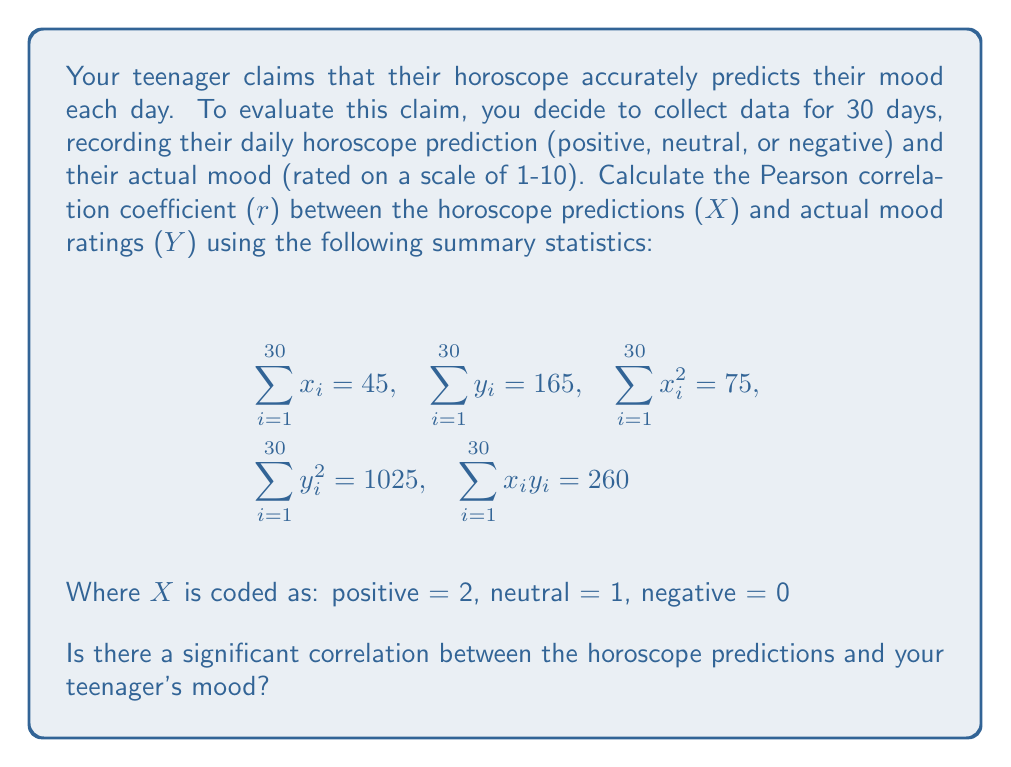Help me with this question. To calculate the Pearson correlation coefficient (r), we'll use the formula:

$$r = \frac{n\sum x_iy_i - (\sum x_i)(\sum y_i)}{\sqrt{[n\sum x_i^2 - (\sum x_i)^2][n\sum y_i^2 - (\sum y_i)^2]}}$$

Where n = 30 (number of days)

Step 1: Calculate the numerator
$$n\sum x_iy_i - (\sum x_i)(\sum y_i) = 30(260) - (45)(165) = 7800 - 7425 = 375$$

Step 2: Calculate the denominator
First part: $$n\sum x_i^2 - (\sum x_i)^2 = 30(75) - (45)^2 = 2250 - 2025 = 225$$
Second part: $$n\sum y_i^2 - (\sum y_i)^2 = 30(1025) - (165)^2 = 30750 - 27225 = 3525$$

Multiply these: $$225 * 3525 = 793125$$

Take the square root: $$\sqrt{793125} = 890.58$$

Step 3: Divide the numerator by the denominator
$$r = \frac{375}{890.58} = 0.4211$$

The Pearson correlation coefficient is approximately 0.4211.

To interpret this result:
- The correlation coefficient ranges from -1 to 1.
- 0.4211 indicates a moderate positive correlation.
- However, correlation does not imply causation.

To determine if this correlation is statistically significant, we would need to perform a hypothesis test, which is beyond the scope of this question.
Answer: $r \approx 0.4211$ (moderate positive correlation) 